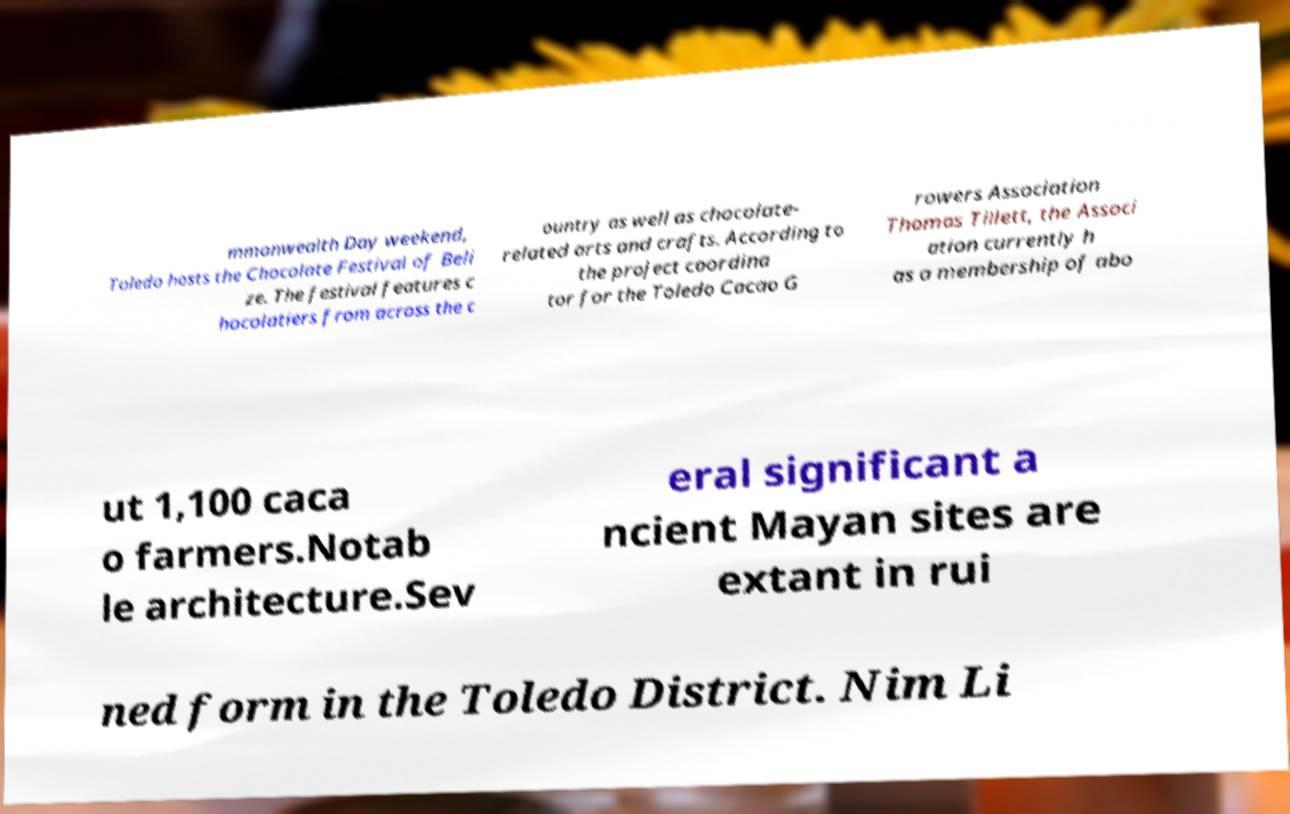For documentation purposes, I need the text within this image transcribed. Could you provide that? mmonwealth Day weekend, Toledo hosts the Chocolate Festival of Beli ze. The festival features c hocolatiers from across the c ountry as well as chocolate- related arts and crafts. According to the project coordina tor for the Toledo Cacao G rowers Association Thomas Tillett, the Associ ation currently h as a membership of abo ut 1,100 caca o farmers.Notab le architecture.Sev eral significant a ncient Mayan sites are extant in rui ned form in the Toledo District. Nim Li 